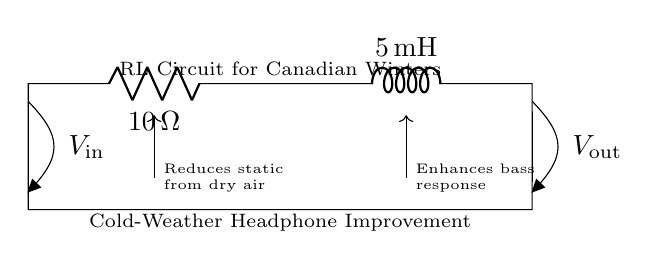What is the resistance in this circuit? The circuit shows a resistor labeled \( R_{\text{warm}} \) with a specified value of 10 ohms. This directly answers the question regarding the resistance in the circuit.
Answer: 10 ohms What is the inductance in this circuit? The circuit contains an inductor labeled \( L_{\text{cozy}} \) with a specified value of 5 millihenries. This is the inductance in the circuit.
Answer: 5 millihenries What does the circuit aim to improve? The circuit diagram indicates a note stating "Cold-Weather Headphone Improvement," which implies its purpose is to enhance headphone sound quality in cold weather.
Answer: Sound quality What is the effect of the resistor on static? The diagram mentions that adding the resistor reduces static caused by dry air, which is a common problem in winter conditions due to low humidity. This means the resistor plays a role in stabilizing the signal and reducing noise interference.
Answer: Reduces static How does the inductor affect the bass response? According to the circuit's annotation, the inductor enhances bass response, indicating its function in improving the low-frequency performance of headphones. Inductors in audio circuits can help filter and boost bass frequencies, resulting in a richer audio experience.
Answer: Enhances bass What is the input voltage labeled as in the circuit? The circuit identifies the input voltage as \( V_{\text{in}} \), which indicates the voltage supplied to the circuit. This is a straightforward identifier of the voltage at the input of the circuit.
Answer: V in What connects the resistor and inductor in this circuit? The resistor and inductor are connected in series, as represented by the direct line connecting them in the diagram. In a series configuration, the current flows through both components sequentially.
Answer: Series connection 